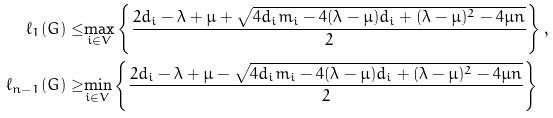<formula> <loc_0><loc_0><loc_500><loc_500>\ell _ { 1 } ( G ) \leq & \underset { i \in V } { \max } \left \{ \frac { 2 d _ { i } - \lambda + \mu + \sqrt { 4 d _ { i } m _ { i } - 4 ( \lambda - \mu ) d _ { i } + ( \lambda - \mu ) ^ { 2 } - 4 \mu n } } { 2 } \right \} , \\ \ell _ { n - 1 } ( G ) \geq & \underset { i \in V } { \min } \left \{ \frac { 2 d _ { i } - \lambda + \mu - \sqrt { 4 d _ { i } m _ { i } - 4 ( \lambda - \mu ) d _ { i } + ( \lambda - \mu ) ^ { 2 } - 4 \mu n } } { 2 } \right \} \\</formula> 